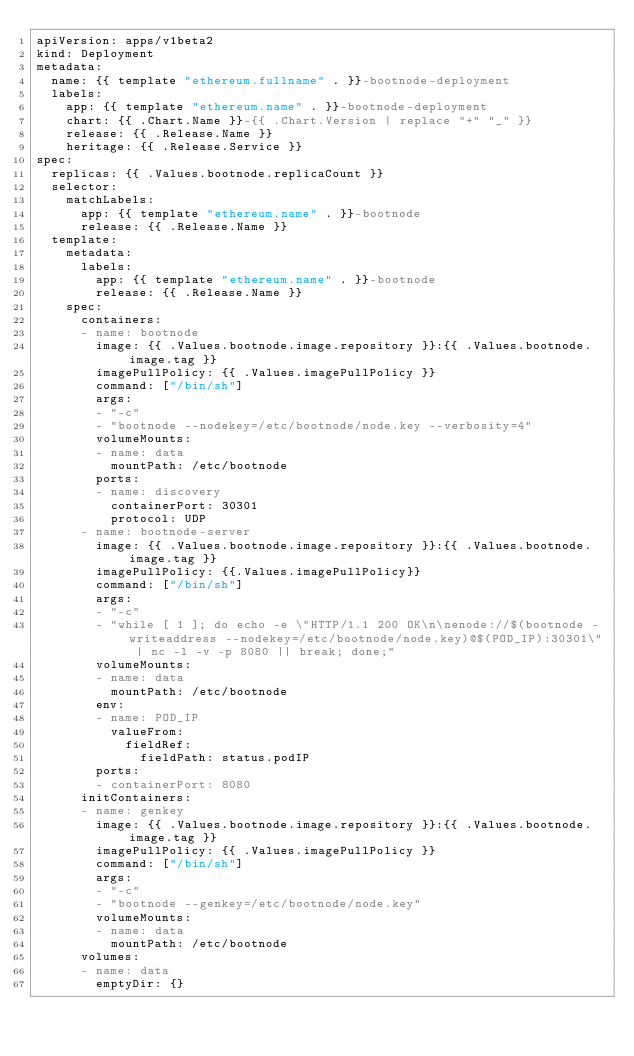Convert code to text. <code><loc_0><loc_0><loc_500><loc_500><_YAML_>apiVersion: apps/v1beta2 
kind: Deployment
metadata:
  name: {{ template "ethereum.fullname" . }}-bootnode-deployment
  labels:
    app: {{ template "ethereum.name" . }}-bootnode-deployment
    chart: {{ .Chart.Name }}-{{ .Chart.Version | replace "+" "_" }}
    release: {{ .Release.Name }}
    heritage: {{ .Release.Service }}
spec:
  replicas: {{ .Values.bootnode.replicaCount }}
  selector:
    matchLabels:
      app: {{ template "ethereum.name" . }}-bootnode
      release: {{ .Release.Name }}
  template:
    metadata:
      labels:
        app: {{ template "ethereum.name" . }}-bootnode
        release: {{ .Release.Name }}
    spec:
      containers:
      - name: bootnode
        image: {{ .Values.bootnode.image.repository }}:{{ .Values.bootnode.image.tag }}
        imagePullPolicy: {{ .Values.imagePullPolicy }}
        command: ["/bin/sh"]
        args: 
        - "-c"
        - "bootnode --nodekey=/etc/bootnode/node.key --verbosity=4"
        volumeMounts:
        - name: data
          mountPath: /etc/bootnode
        ports:
        - name: discovery
          containerPort: 30301
          protocol: UDP
      - name: bootnode-server
        image: {{ .Values.bootnode.image.repository }}:{{ .Values.bootnode.image.tag }}
        imagePullPolicy: {{.Values.imagePullPolicy}}
        command: ["/bin/sh"]
        args:
        - "-c"
        - "while [ 1 ]; do echo -e \"HTTP/1.1 200 OK\n\nenode://$(bootnode -writeaddress --nodekey=/etc/bootnode/node.key)@$(POD_IP):30301\" | nc -l -v -p 8080 || break; done;"
        volumeMounts:
        - name: data
          mountPath: /etc/bootnode
        env:
        - name: POD_IP
          valueFrom:
            fieldRef:
              fieldPath: status.podIP
        ports:
        - containerPort: 8080
      initContainers:
      - name: genkey
        image: {{ .Values.bootnode.image.repository }}:{{ .Values.bootnode.image.tag }}
        imagePullPolicy: {{ .Values.imagePullPolicy }}
        command: ["/bin/sh"]
        args:
        - "-c"
        - "bootnode --genkey=/etc/bootnode/node.key"
        volumeMounts:
        - name: data
          mountPath: /etc/bootnode
      volumes:
      - name: data
        emptyDir: {}
</code> 